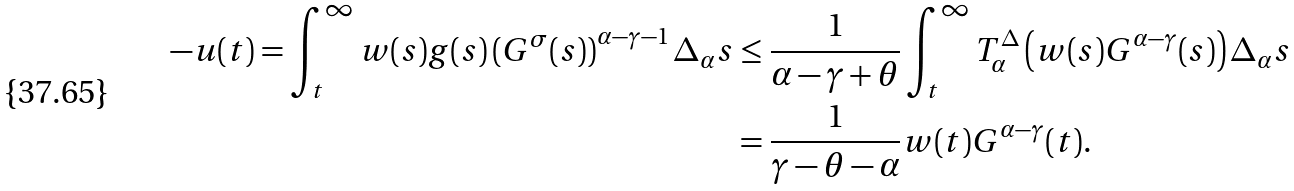<formula> <loc_0><loc_0><loc_500><loc_500>- u ( t ) = \int _ { t } ^ { \infty } w ( s ) g ( s ) \left ( G ^ { \sigma } ( s ) \right ) ^ { \alpha - \gamma - 1 } \Delta _ { \alpha } s & \leq \frac { 1 } { \alpha - \gamma + \theta } \int _ { t } ^ { \infty } T ^ { \Delta } _ { \alpha } \left ( w ( s ) G ^ { \alpha - \gamma } ( s ) \right ) \Delta _ { \alpha } s \\ & = \frac { 1 } { \gamma - \theta - \alpha } w ( t ) G ^ { \alpha - \gamma } ( t ) .</formula> 